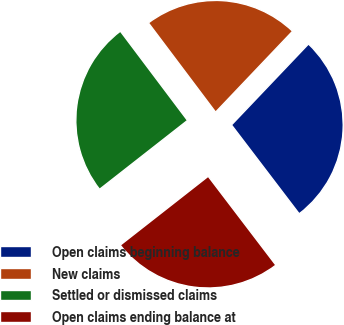Convert chart to OTSL. <chart><loc_0><loc_0><loc_500><loc_500><pie_chart><fcel>Open claims beginning balance<fcel>New claims<fcel>Settled or dismissed claims<fcel>Open claims ending balance at<nl><fcel>27.54%<fcel>22.37%<fcel>25.31%<fcel>24.79%<nl></chart> 